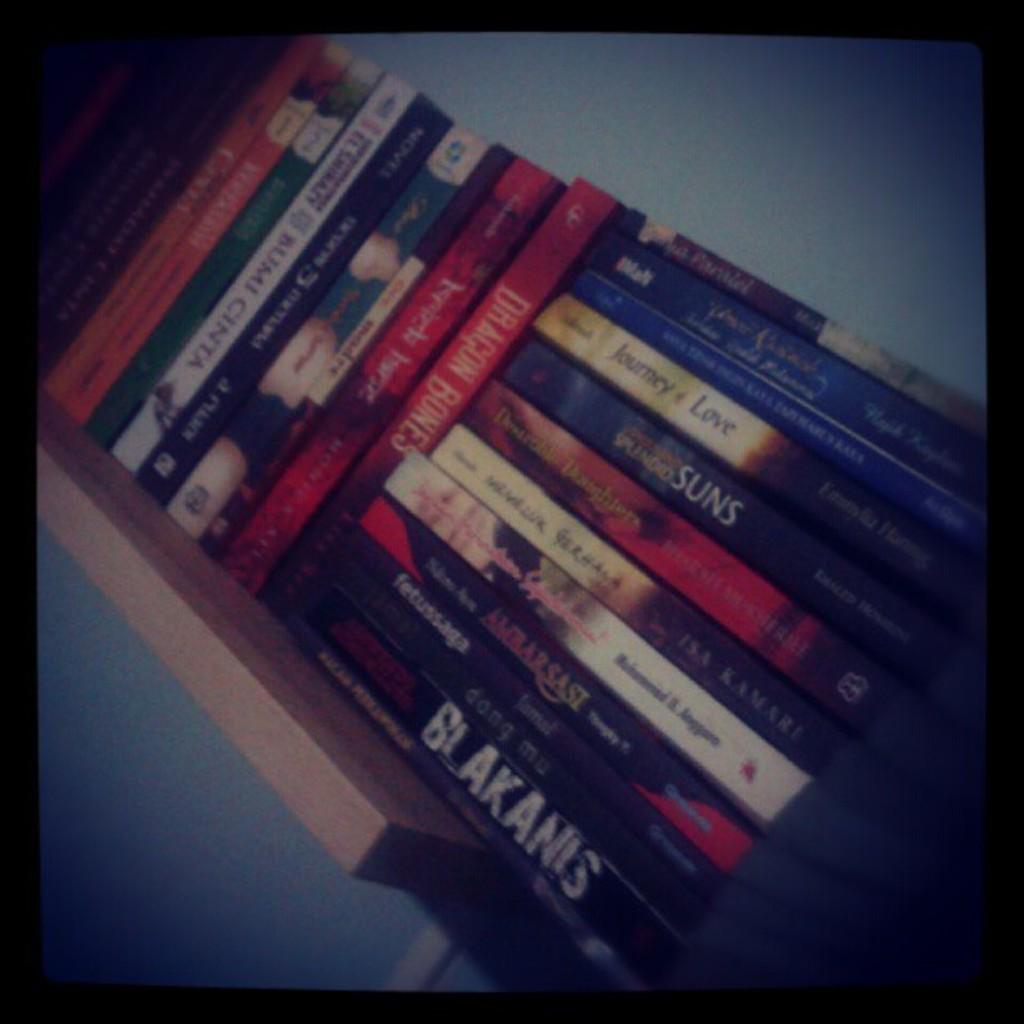What is the name of the last book which is in black color?
Ensure brevity in your answer.  Blakanis. 